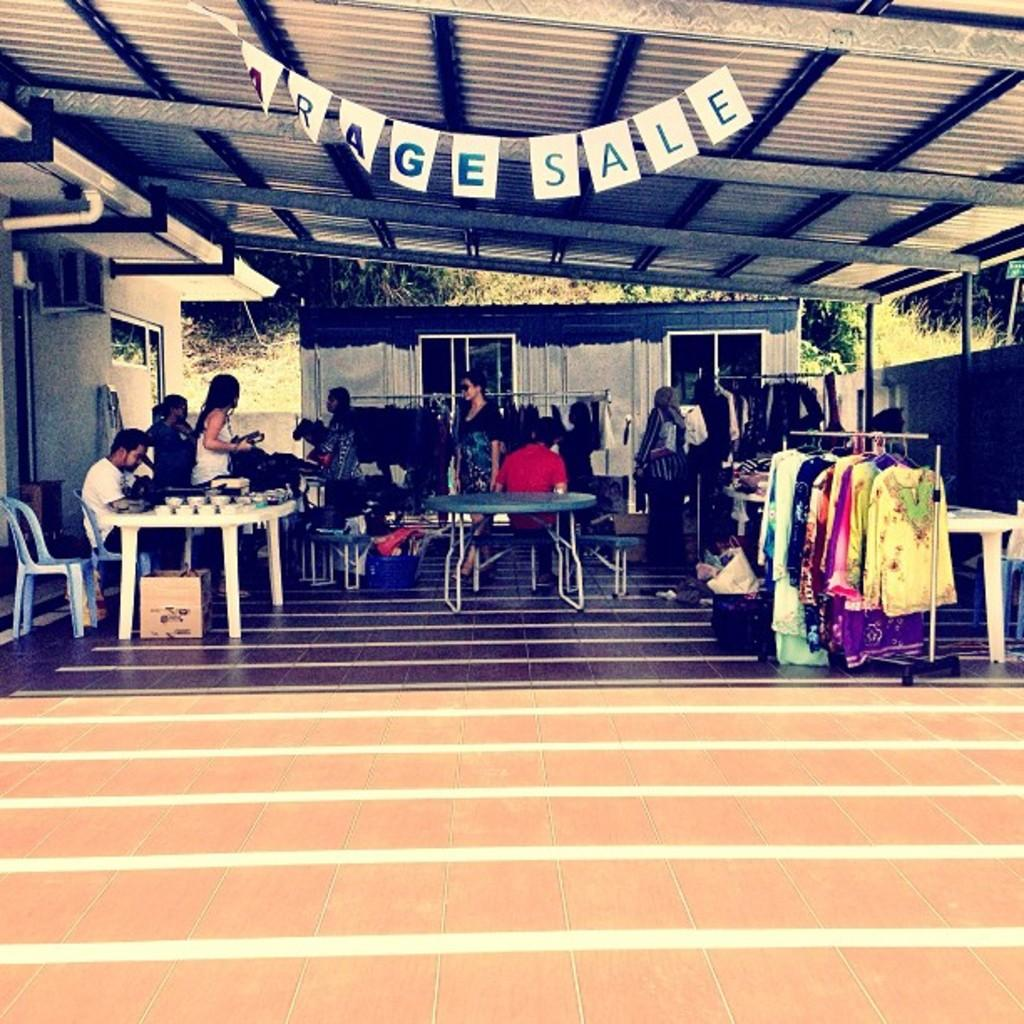How many people are in the image? There are people in the image, but the exact number is not specified. What are the people doing in the image? One person is sitting, while others are standing. What type of furniture is present in the image? There are tables and chairs in the image. What can be seen hanging or draped in the image? Clothes are visible in the image. What type of natural scenery is present in the image? There are trees in the image. What degree of difficulty is the person swimming in the image? There is no person swimming in the image; it only shows people sitting, standing, and wearing clothes. How many fingers does the person pointing in the image have? There is no person pointing in the image; it only shows people sitting, standing, and wearing clothes. 